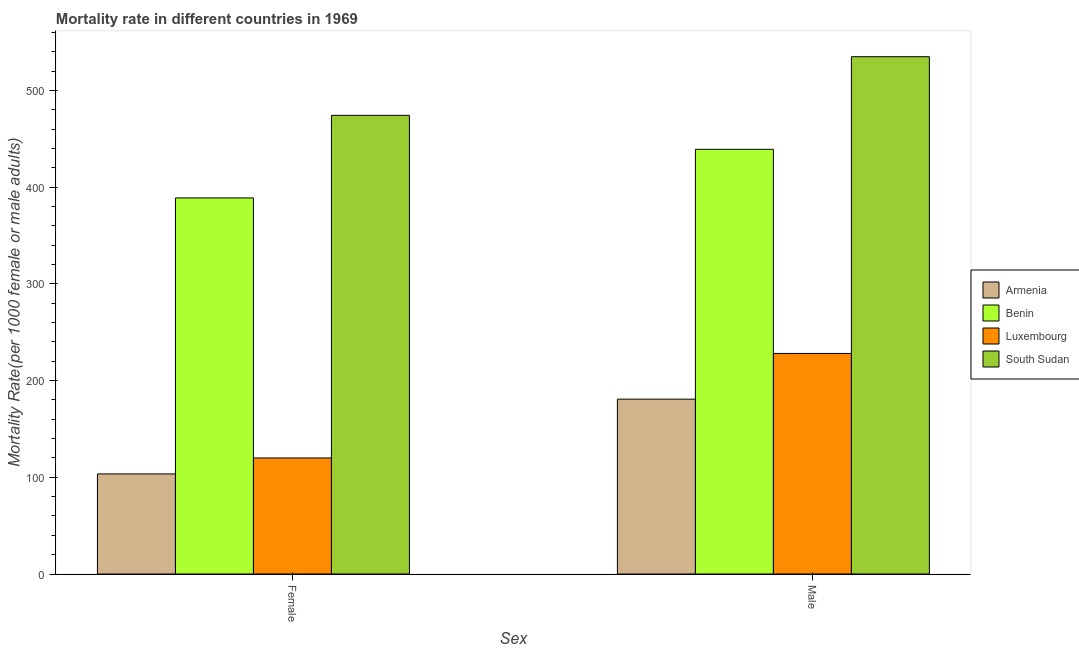How many different coloured bars are there?
Give a very brief answer. 4. How many groups of bars are there?
Keep it short and to the point. 2. Are the number of bars per tick equal to the number of legend labels?
Your response must be concise. Yes. What is the male mortality rate in Luxembourg?
Make the answer very short. 228.05. Across all countries, what is the maximum female mortality rate?
Make the answer very short. 474.2. Across all countries, what is the minimum male mortality rate?
Provide a succinct answer. 180.78. In which country was the female mortality rate maximum?
Give a very brief answer. South Sudan. In which country was the female mortality rate minimum?
Provide a succinct answer. Armenia. What is the total male mortality rate in the graph?
Keep it short and to the point. 1382.77. What is the difference between the female mortality rate in South Sudan and that in Benin?
Your answer should be very brief. 85.36. What is the difference between the male mortality rate in Armenia and the female mortality rate in South Sudan?
Make the answer very short. -293.42. What is the average female mortality rate per country?
Ensure brevity in your answer.  271.63. What is the difference between the male mortality rate and female mortality rate in Armenia?
Give a very brief answer. 77.3. What is the ratio of the female mortality rate in Luxembourg to that in Benin?
Make the answer very short. 0.31. Is the female mortality rate in Benin less than that in Luxembourg?
Provide a succinct answer. No. In how many countries, is the male mortality rate greater than the average male mortality rate taken over all countries?
Offer a very short reply. 2. What does the 2nd bar from the left in Female represents?
Offer a terse response. Benin. What does the 2nd bar from the right in Female represents?
Ensure brevity in your answer.  Luxembourg. Are all the bars in the graph horizontal?
Offer a terse response. No. How many countries are there in the graph?
Provide a short and direct response. 4. What is the difference between two consecutive major ticks on the Y-axis?
Ensure brevity in your answer.  100. Are the values on the major ticks of Y-axis written in scientific E-notation?
Give a very brief answer. No. Does the graph contain any zero values?
Ensure brevity in your answer.  No. How many legend labels are there?
Ensure brevity in your answer.  4. What is the title of the graph?
Your response must be concise. Mortality rate in different countries in 1969. What is the label or title of the X-axis?
Ensure brevity in your answer.  Sex. What is the label or title of the Y-axis?
Your response must be concise. Mortality Rate(per 1000 female or male adults). What is the Mortality Rate(per 1000 female or male adults) of Armenia in Female?
Offer a very short reply. 103.48. What is the Mortality Rate(per 1000 female or male adults) of Benin in Female?
Your response must be concise. 388.84. What is the Mortality Rate(per 1000 female or male adults) in Luxembourg in Female?
Your response must be concise. 119.99. What is the Mortality Rate(per 1000 female or male adults) in South Sudan in Female?
Provide a short and direct response. 474.2. What is the Mortality Rate(per 1000 female or male adults) in Armenia in Male?
Offer a very short reply. 180.78. What is the Mortality Rate(per 1000 female or male adults) of Benin in Male?
Your answer should be very brief. 439.1. What is the Mortality Rate(per 1000 female or male adults) in Luxembourg in Male?
Your response must be concise. 228.05. What is the Mortality Rate(per 1000 female or male adults) in South Sudan in Male?
Offer a very short reply. 534.85. Across all Sex, what is the maximum Mortality Rate(per 1000 female or male adults) of Armenia?
Offer a very short reply. 180.78. Across all Sex, what is the maximum Mortality Rate(per 1000 female or male adults) of Benin?
Ensure brevity in your answer.  439.1. Across all Sex, what is the maximum Mortality Rate(per 1000 female or male adults) in Luxembourg?
Your answer should be very brief. 228.05. Across all Sex, what is the maximum Mortality Rate(per 1000 female or male adults) in South Sudan?
Offer a terse response. 534.85. Across all Sex, what is the minimum Mortality Rate(per 1000 female or male adults) in Armenia?
Offer a very short reply. 103.48. Across all Sex, what is the minimum Mortality Rate(per 1000 female or male adults) in Benin?
Provide a succinct answer. 388.84. Across all Sex, what is the minimum Mortality Rate(per 1000 female or male adults) of Luxembourg?
Provide a short and direct response. 119.99. Across all Sex, what is the minimum Mortality Rate(per 1000 female or male adults) of South Sudan?
Offer a terse response. 474.2. What is the total Mortality Rate(per 1000 female or male adults) in Armenia in the graph?
Provide a succinct answer. 284.25. What is the total Mortality Rate(per 1000 female or male adults) of Benin in the graph?
Provide a succinct answer. 827.94. What is the total Mortality Rate(per 1000 female or male adults) in Luxembourg in the graph?
Your answer should be very brief. 348.05. What is the total Mortality Rate(per 1000 female or male adults) of South Sudan in the graph?
Provide a succinct answer. 1009.04. What is the difference between the Mortality Rate(per 1000 female or male adults) of Armenia in Female and that in Male?
Provide a succinct answer. -77.3. What is the difference between the Mortality Rate(per 1000 female or male adults) in Benin in Female and that in Male?
Keep it short and to the point. -50.26. What is the difference between the Mortality Rate(per 1000 female or male adults) of Luxembourg in Female and that in Male?
Make the answer very short. -108.06. What is the difference between the Mortality Rate(per 1000 female or male adults) of South Sudan in Female and that in Male?
Your answer should be very brief. -60.65. What is the difference between the Mortality Rate(per 1000 female or male adults) in Armenia in Female and the Mortality Rate(per 1000 female or male adults) in Benin in Male?
Provide a short and direct response. -335.62. What is the difference between the Mortality Rate(per 1000 female or male adults) in Armenia in Female and the Mortality Rate(per 1000 female or male adults) in Luxembourg in Male?
Provide a short and direct response. -124.58. What is the difference between the Mortality Rate(per 1000 female or male adults) of Armenia in Female and the Mortality Rate(per 1000 female or male adults) of South Sudan in Male?
Your answer should be compact. -431.37. What is the difference between the Mortality Rate(per 1000 female or male adults) of Benin in Female and the Mortality Rate(per 1000 female or male adults) of Luxembourg in Male?
Give a very brief answer. 160.79. What is the difference between the Mortality Rate(per 1000 female or male adults) in Benin in Female and the Mortality Rate(per 1000 female or male adults) in South Sudan in Male?
Offer a terse response. -146.01. What is the difference between the Mortality Rate(per 1000 female or male adults) in Luxembourg in Female and the Mortality Rate(per 1000 female or male adults) in South Sudan in Male?
Keep it short and to the point. -414.85. What is the average Mortality Rate(per 1000 female or male adults) of Armenia per Sex?
Offer a very short reply. 142.13. What is the average Mortality Rate(per 1000 female or male adults) in Benin per Sex?
Offer a terse response. 413.97. What is the average Mortality Rate(per 1000 female or male adults) in Luxembourg per Sex?
Your answer should be very brief. 174.02. What is the average Mortality Rate(per 1000 female or male adults) of South Sudan per Sex?
Provide a short and direct response. 504.52. What is the difference between the Mortality Rate(per 1000 female or male adults) of Armenia and Mortality Rate(per 1000 female or male adults) of Benin in Female?
Ensure brevity in your answer.  -285.36. What is the difference between the Mortality Rate(per 1000 female or male adults) of Armenia and Mortality Rate(per 1000 female or male adults) of Luxembourg in Female?
Ensure brevity in your answer.  -16.52. What is the difference between the Mortality Rate(per 1000 female or male adults) of Armenia and Mortality Rate(per 1000 female or male adults) of South Sudan in Female?
Your response must be concise. -370.72. What is the difference between the Mortality Rate(per 1000 female or male adults) of Benin and Mortality Rate(per 1000 female or male adults) of Luxembourg in Female?
Provide a succinct answer. 268.85. What is the difference between the Mortality Rate(per 1000 female or male adults) in Benin and Mortality Rate(per 1000 female or male adults) in South Sudan in Female?
Offer a terse response. -85.36. What is the difference between the Mortality Rate(per 1000 female or male adults) of Luxembourg and Mortality Rate(per 1000 female or male adults) of South Sudan in Female?
Keep it short and to the point. -354.21. What is the difference between the Mortality Rate(per 1000 female or male adults) of Armenia and Mortality Rate(per 1000 female or male adults) of Benin in Male?
Make the answer very short. -258.32. What is the difference between the Mortality Rate(per 1000 female or male adults) in Armenia and Mortality Rate(per 1000 female or male adults) in Luxembourg in Male?
Your answer should be compact. -47.27. What is the difference between the Mortality Rate(per 1000 female or male adults) of Armenia and Mortality Rate(per 1000 female or male adults) of South Sudan in Male?
Your answer should be very brief. -354.07. What is the difference between the Mortality Rate(per 1000 female or male adults) in Benin and Mortality Rate(per 1000 female or male adults) in Luxembourg in Male?
Your answer should be very brief. 211.05. What is the difference between the Mortality Rate(per 1000 female or male adults) in Benin and Mortality Rate(per 1000 female or male adults) in South Sudan in Male?
Give a very brief answer. -95.75. What is the difference between the Mortality Rate(per 1000 female or male adults) in Luxembourg and Mortality Rate(per 1000 female or male adults) in South Sudan in Male?
Make the answer very short. -306.79. What is the ratio of the Mortality Rate(per 1000 female or male adults) in Armenia in Female to that in Male?
Your response must be concise. 0.57. What is the ratio of the Mortality Rate(per 1000 female or male adults) of Benin in Female to that in Male?
Provide a succinct answer. 0.89. What is the ratio of the Mortality Rate(per 1000 female or male adults) of Luxembourg in Female to that in Male?
Keep it short and to the point. 0.53. What is the ratio of the Mortality Rate(per 1000 female or male adults) in South Sudan in Female to that in Male?
Ensure brevity in your answer.  0.89. What is the difference between the highest and the second highest Mortality Rate(per 1000 female or male adults) in Armenia?
Keep it short and to the point. 77.3. What is the difference between the highest and the second highest Mortality Rate(per 1000 female or male adults) of Benin?
Keep it short and to the point. 50.26. What is the difference between the highest and the second highest Mortality Rate(per 1000 female or male adults) of Luxembourg?
Your answer should be very brief. 108.06. What is the difference between the highest and the second highest Mortality Rate(per 1000 female or male adults) in South Sudan?
Provide a short and direct response. 60.65. What is the difference between the highest and the lowest Mortality Rate(per 1000 female or male adults) of Armenia?
Provide a succinct answer. 77.3. What is the difference between the highest and the lowest Mortality Rate(per 1000 female or male adults) of Benin?
Provide a succinct answer. 50.26. What is the difference between the highest and the lowest Mortality Rate(per 1000 female or male adults) in Luxembourg?
Keep it short and to the point. 108.06. What is the difference between the highest and the lowest Mortality Rate(per 1000 female or male adults) of South Sudan?
Your answer should be compact. 60.65. 